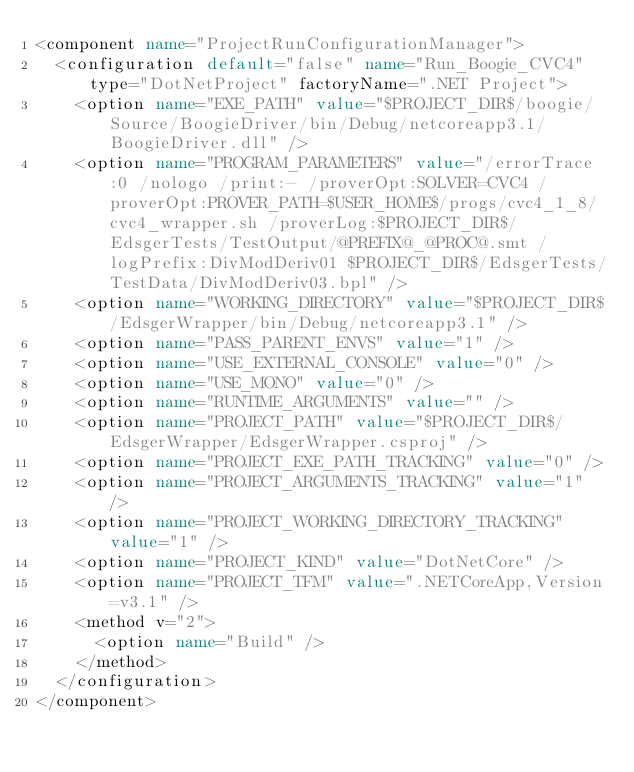<code> <loc_0><loc_0><loc_500><loc_500><_XML_><component name="ProjectRunConfigurationManager">
  <configuration default="false" name="Run_Boogie_CVC4" type="DotNetProject" factoryName=".NET Project">
    <option name="EXE_PATH" value="$PROJECT_DIR$/boogie/Source/BoogieDriver/bin/Debug/netcoreapp3.1/BoogieDriver.dll" />
    <option name="PROGRAM_PARAMETERS" value="/errorTrace:0 /nologo /print:- /proverOpt:SOLVER=CVC4 /proverOpt:PROVER_PATH=$USER_HOME$/progs/cvc4_1_8/cvc4_wrapper.sh /proverLog:$PROJECT_DIR$/EdsgerTests/TestOutput/@PREFIX@_@PROC@.smt /logPrefix:DivModDeriv01 $PROJECT_DIR$/EdsgerTests/TestData/DivModDeriv03.bpl" />
    <option name="WORKING_DIRECTORY" value="$PROJECT_DIR$/EdsgerWrapper/bin/Debug/netcoreapp3.1" />
    <option name="PASS_PARENT_ENVS" value="1" />
    <option name="USE_EXTERNAL_CONSOLE" value="0" />
    <option name="USE_MONO" value="0" />
    <option name="RUNTIME_ARGUMENTS" value="" />
    <option name="PROJECT_PATH" value="$PROJECT_DIR$/EdsgerWrapper/EdsgerWrapper.csproj" />
    <option name="PROJECT_EXE_PATH_TRACKING" value="0" />
    <option name="PROJECT_ARGUMENTS_TRACKING" value="1" />
    <option name="PROJECT_WORKING_DIRECTORY_TRACKING" value="1" />
    <option name="PROJECT_KIND" value="DotNetCore" />
    <option name="PROJECT_TFM" value=".NETCoreApp,Version=v3.1" />
    <method v="2">
      <option name="Build" />
    </method>
  </configuration>
</component></code> 